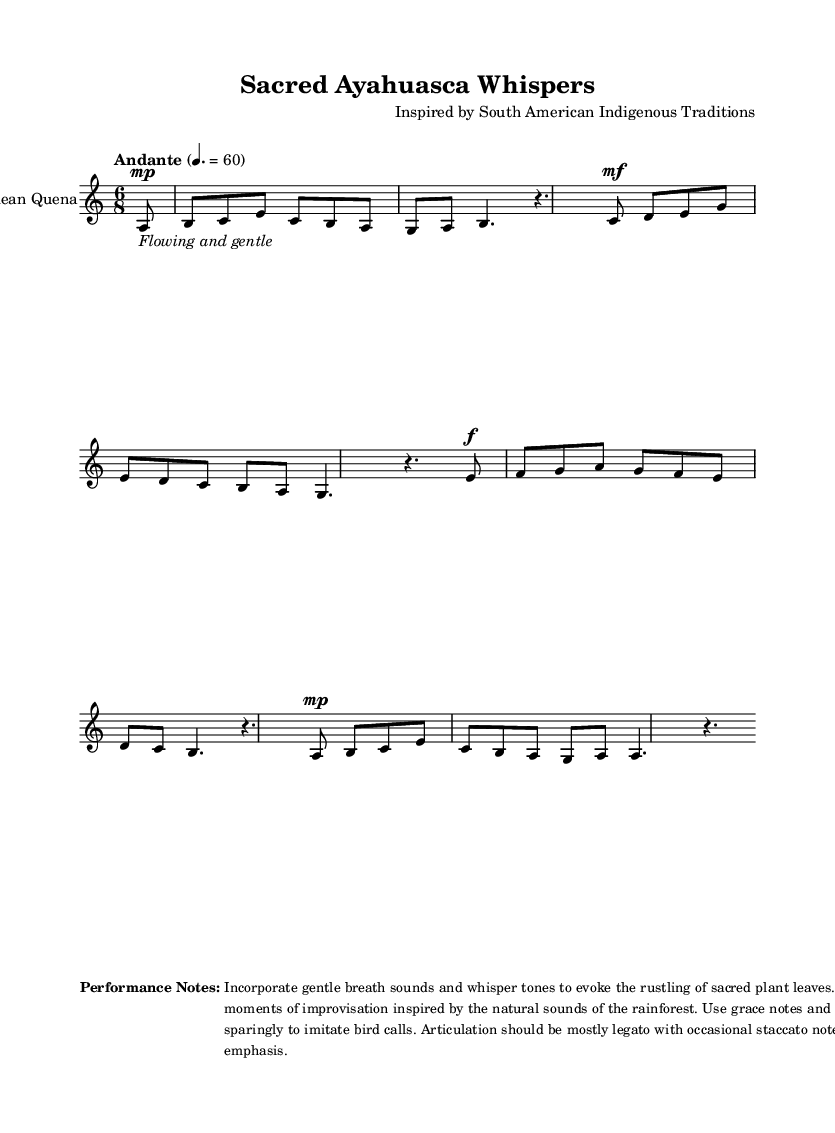What is the key signature of this music? The key signature indicates that the piece is in A minor, which has no sharps or flats.
Answer: A minor What is the time signature of the score? The time signature is indicated at the beginning as 6/8, which means there are six eighth notes per measure.
Answer: 6/8 What is the tempo marking for this piece? The tempo marking states "Andante" with a metronome indication of 60 beats per minute.
Answer: Andante How many measures are included in this section of the music? By counting the bars indicated in the score, there are a total of eight measures present in this section.
Answer: 8 What is the dynamic marking for the first phrase? The first phrase features a dynamic marking of "mp," which means "mezzo-piano" or moderately soft.
Answer: mezzo-piano What performance techniques are suggested in the notes? The performance notes suggest using gentle breath sounds, improvisation, grace notes, and trills, emphasizing a natural and flowing sound.
Answer: Gentle breath sounds What instrument is specified for this piece? The score clearly states that the instrument is an "Indigenous Andean Quena," a traditional South American flute.
Answer: Indigenous Andean Quena 